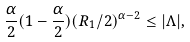Convert formula to latex. <formula><loc_0><loc_0><loc_500><loc_500>\frac { \alpha } { 2 } ( 1 - \frac { \alpha } { 2 } ) ( R _ { 1 } / 2 ) ^ { \alpha - 2 } \leq | \Lambda | ,</formula> 